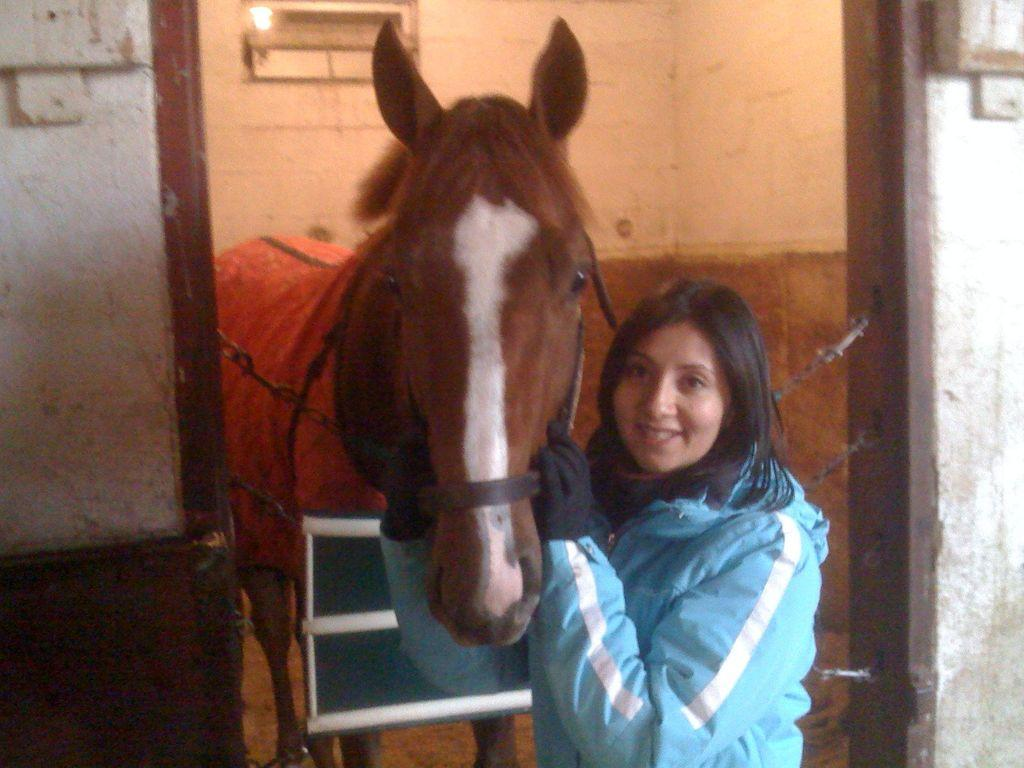Who is present in the image? There is a woman in the image. What animal is also present in the image? There is a horse in the image. How are the woman and the horse positioned in relation to each other? The woman is standing with the horse. How many boys are sitting inside the box in the image? There are no boys or boxes present in the image. 